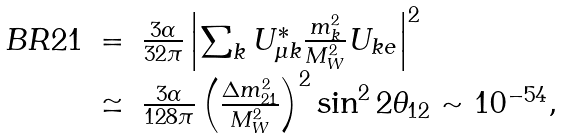Convert formula to latex. <formula><loc_0><loc_0><loc_500><loc_500>\begin{array} { r c l } B R 2 1 & = & \frac { 3 \alpha } { 3 2 \pi } \left | \sum _ { k } U ^ { * } _ { \mu k } \frac { m ^ { 2 } _ { k } } { M ^ { 2 } _ { W } } U _ { k e } \right | ^ { 2 } \\ & \simeq & \frac { 3 \alpha } { 1 2 8 \pi } \left ( \frac { \Delta m ^ { 2 } _ { 2 1 } } { M ^ { 2 } _ { W } } \right ) ^ { 2 } \sin ^ { 2 } 2 \theta _ { 1 2 } \sim 1 0 ^ { - 5 4 } , \\ \end{array}</formula> 